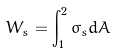<formula> <loc_0><loc_0><loc_500><loc_500>W _ { s } = \int _ { 1 } ^ { 2 } \sigma _ { s } d A</formula> 